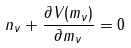Convert formula to latex. <formula><loc_0><loc_0><loc_500><loc_500>n _ { \nu } + \frac { \partial V ( m _ { \nu } ) } { \partial m _ { \nu } } = 0</formula> 